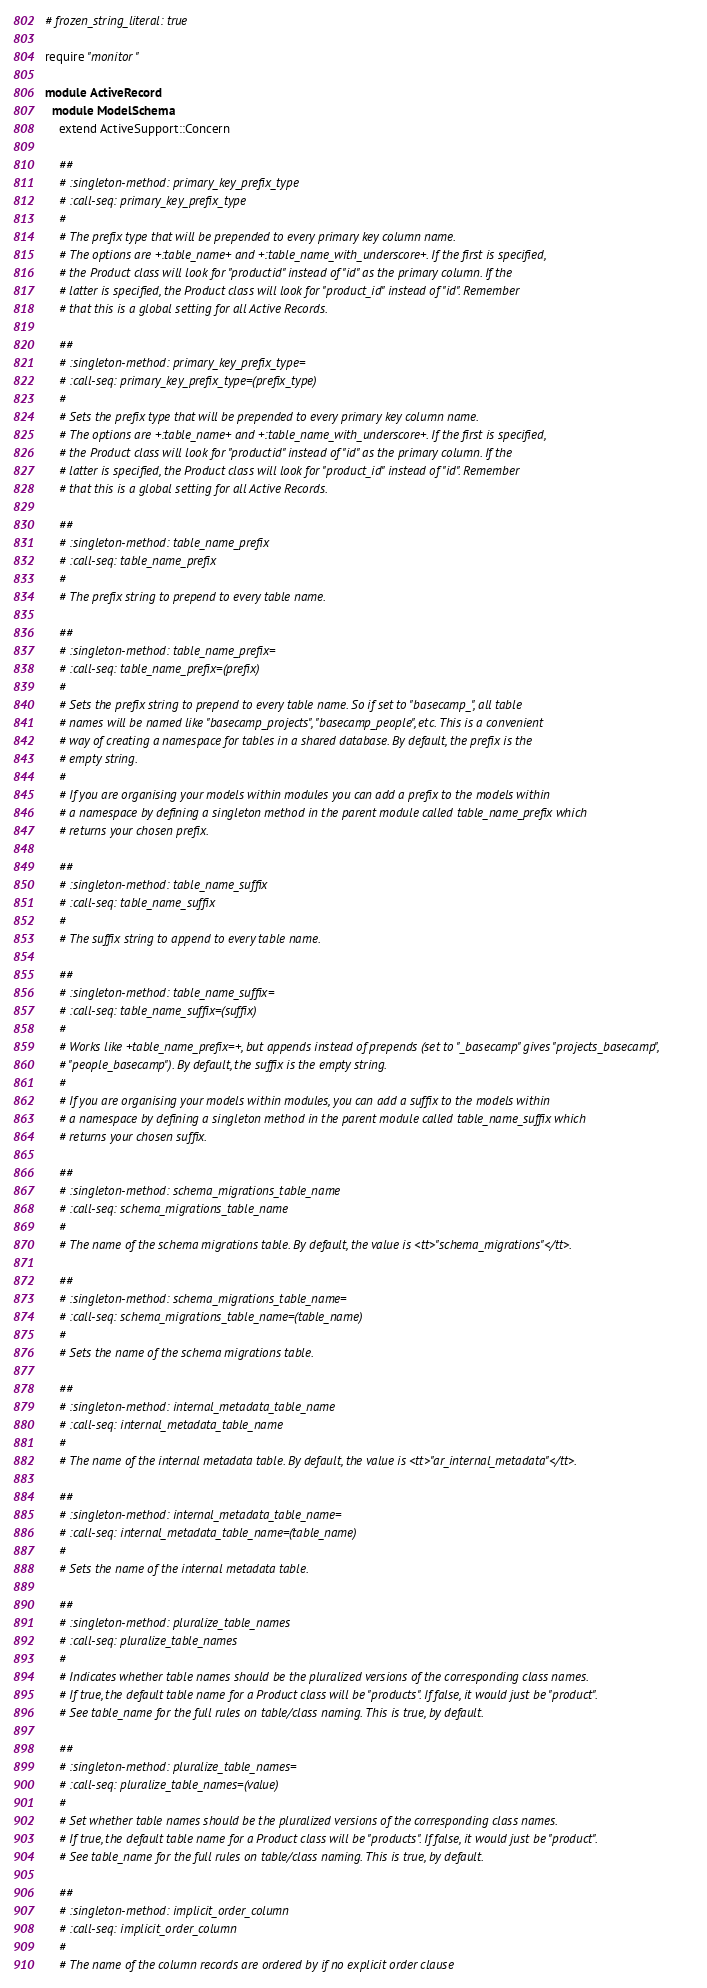Convert code to text. <code><loc_0><loc_0><loc_500><loc_500><_Ruby_># frozen_string_literal: true

require "monitor"

module ActiveRecord
  module ModelSchema
    extend ActiveSupport::Concern

    ##
    # :singleton-method: primary_key_prefix_type
    # :call-seq: primary_key_prefix_type
    #
    # The prefix type that will be prepended to every primary key column name.
    # The options are +:table_name+ and +:table_name_with_underscore+. If the first is specified,
    # the Product class will look for "productid" instead of "id" as the primary column. If the
    # latter is specified, the Product class will look for "product_id" instead of "id". Remember
    # that this is a global setting for all Active Records.

    ##
    # :singleton-method: primary_key_prefix_type=
    # :call-seq: primary_key_prefix_type=(prefix_type)
    #
    # Sets the prefix type that will be prepended to every primary key column name.
    # The options are +:table_name+ and +:table_name_with_underscore+. If the first is specified,
    # the Product class will look for "productid" instead of "id" as the primary column. If the
    # latter is specified, the Product class will look for "product_id" instead of "id". Remember
    # that this is a global setting for all Active Records.

    ##
    # :singleton-method: table_name_prefix
    # :call-seq: table_name_prefix
    #
    # The prefix string to prepend to every table name.

    ##
    # :singleton-method: table_name_prefix=
    # :call-seq: table_name_prefix=(prefix)
    #
    # Sets the prefix string to prepend to every table name. So if set to "basecamp_", all table
    # names will be named like "basecamp_projects", "basecamp_people", etc. This is a convenient
    # way of creating a namespace for tables in a shared database. By default, the prefix is the
    # empty string.
    #
    # If you are organising your models within modules you can add a prefix to the models within
    # a namespace by defining a singleton method in the parent module called table_name_prefix which
    # returns your chosen prefix.

    ##
    # :singleton-method: table_name_suffix
    # :call-seq: table_name_suffix
    #
    # The suffix string to append to every table name.

    ##
    # :singleton-method: table_name_suffix=
    # :call-seq: table_name_suffix=(suffix)
    #
    # Works like +table_name_prefix=+, but appends instead of prepends (set to "_basecamp" gives "projects_basecamp",
    # "people_basecamp"). By default, the suffix is the empty string.
    #
    # If you are organising your models within modules, you can add a suffix to the models within
    # a namespace by defining a singleton method in the parent module called table_name_suffix which
    # returns your chosen suffix.

    ##
    # :singleton-method: schema_migrations_table_name
    # :call-seq: schema_migrations_table_name
    #
    # The name of the schema migrations table. By default, the value is <tt>"schema_migrations"</tt>.

    ##
    # :singleton-method: schema_migrations_table_name=
    # :call-seq: schema_migrations_table_name=(table_name)
    #
    # Sets the name of the schema migrations table.

    ##
    # :singleton-method: internal_metadata_table_name
    # :call-seq: internal_metadata_table_name
    #
    # The name of the internal metadata table. By default, the value is <tt>"ar_internal_metadata"</tt>.

    ##
    # :singleton-method: internal_metadata_table_name=
    # :call-seq: internal_metadata_table_name=(table_name)
    #
    # Sets the name of the internal metadata table.

    ##
    # :singleton-method: pluralize_table_names
    # :call-seq: pluralize_table_names
    #
    # Indicates whether table names should be the pluralized versions of the corresponding class names.
    # If true, the default table name for a Product class will be "products". If false, it would just be "product".
    # See table_name for the full rules on table/class naming. This is true, by default.

    ##
    # :singleton-method: pluralize_table_names=
    # :call-seq: pluralize_table_names=(value)
    #
    # Set whether table names should be the pluralized versions of the corresponding class names.
    # If true, the default table name for a Product class will be "products". If false, it would just be "product".
    # See table_name for the full rules on table/class naming. This is true, by default.

    ##
    # :singleton-method: implicit_order_column
    # :call-seq: implicit_order_column
    #
    # The name of the column records are ordered by if no explicit order clause</code> 